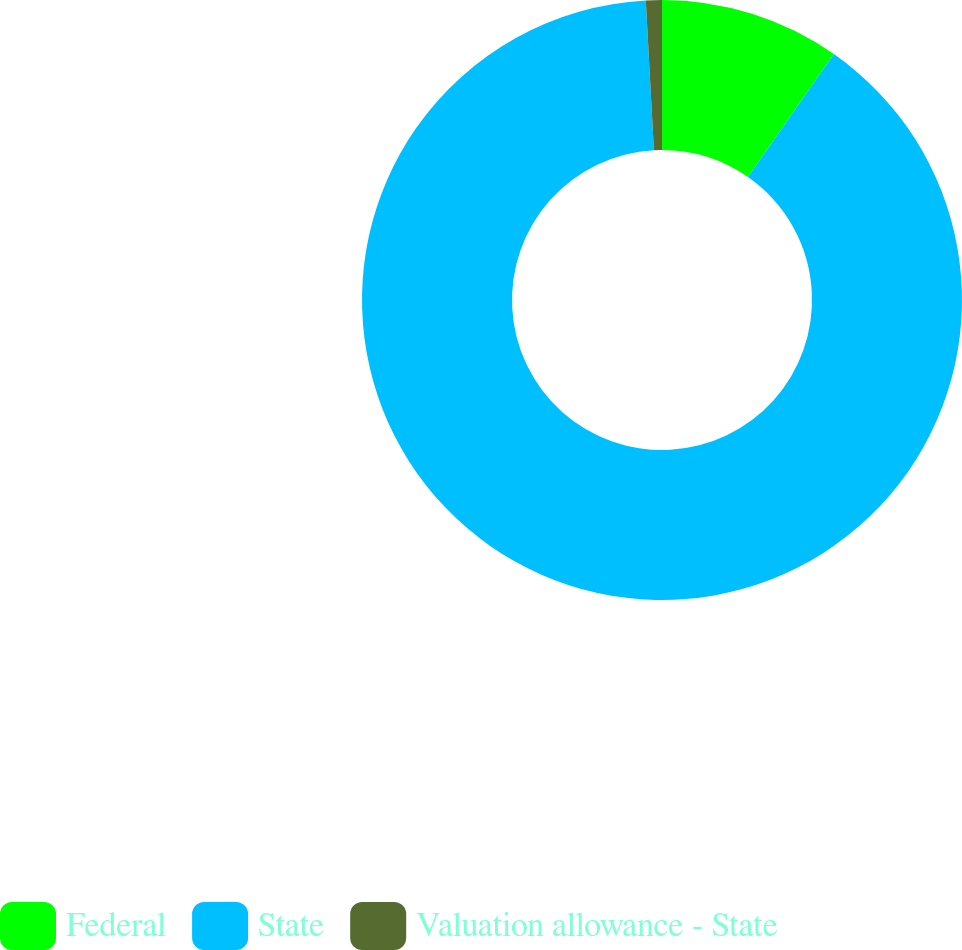Convert chart. <chart><loc_0><loc_0><loc_500><loc_500><pie_chart><fcel>Federal<fcel>State<fcel>Valuation allowance - State<nl><fcel>9.71%<fcel>89.43%<fcel>0.86%<nl></chart> 